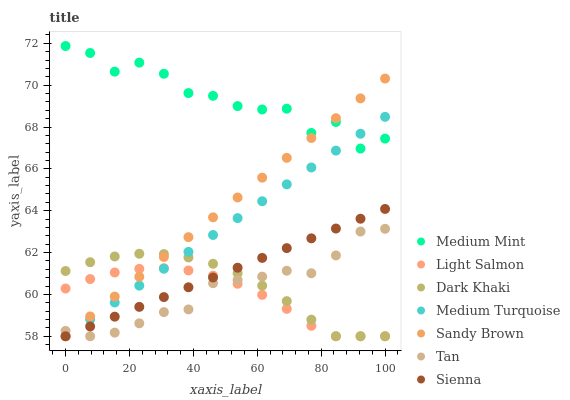Does Light Salmon have the minimum area under the curve?
Answer yes or no. Yes. Does Medium Mint have the maximum area under the curve?
Answer yes or no. Yes. Does Sienna have the minimum area under the curve?
Answer yes or no. No. Does Sienna have the maximum area under the curve?
Answer yes or no. No. Is Medium Turquoise the smoothest?
Answer yes or no. Yes. Is Medium Mint the roughest?
Answer yes or no. Yes. Is Sienna the smoothest?
Answer yes or no. No. Is Sienna the roughest?
Answer yes or no. No. Does Sienna have the lowest value?
Answer yes or no. Yes. Does Medium Mint have the highest value?
Answer yes or no. Yes. Does Sienna have the highest value?
Answer yes or no. No. Is Dark Khaki less than Medium Mint?
Answer yes or no. Yes. Is Medium Mint greater than Dark Khaki?
Answer yes or no. Yes. Does Sienna intersect Sandy Brown?
Answer yes or no. Yes. Is Sienna less than Sandy Brown?
Answer yes or no. No. Is Sienna greater than Sandy Brown?
Answer yes or no. No. Does Dark Khaki intersect Medium Mint?
Answer yes or no. No. 